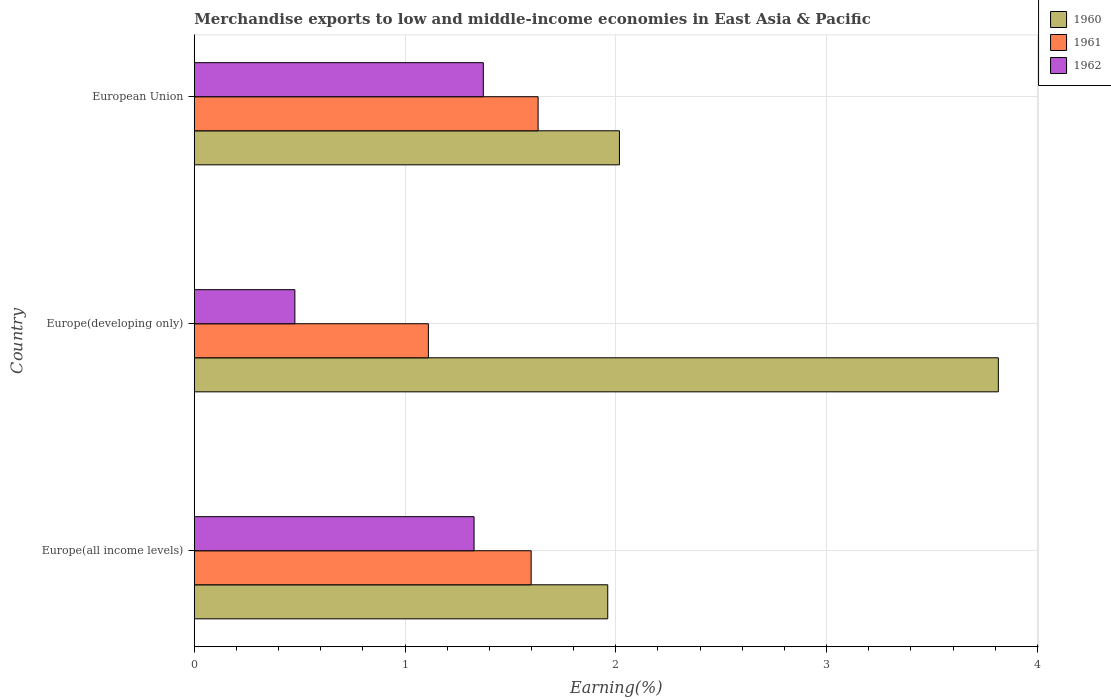How many groups of bars are there?
Offer a terse response. 3. Are the number of bars per tick equal to the number of legend labels?
Keep it short and to the point. Yes. What is the label of the 3rd group of bars from the top?
Your answer should be very brief. Europe(all income levels). What is the percentage of amount earned from merchandise exports in 1961 in European Union?
Offer a very short reply. 1.63. Across all countries, what is the maximum percentage of amount earned from merchandise exports in 1961?
Make the answer very short. 1.63. Across all countries, what is the minimum percentage of amount earned from merchandise exports in 1962?
Make the answer very short. 0.48. In which country was the percentage of amount earned from merchandise exports in 1961 minimum?
Your response must be concise. Europe(developing only). What is the total percentage of amount earned from merchandise exports in 1960 in the graph?
Your response must be concise. 7.79. What is the difference between the percentage of amount earned from merchandise exports in 1962 in Europe(all income levels) and that in European Union?
Provide a short and direct response. -0.04. What is the difference between the percentage of amount earned from merchandise exports in 1962 in Europe(all income levels) and the percentage of amount earned from merchandise exports in 1960 in Europe(developing only)?
Ensure brevity in your answer.  -2.49. What is the average percentage of amount earned from merchandise exports in 1961 per country?
Make the answer very short. 1.45. What is the difference between the percentage of amount earned from merchandise exports in 1960 and percentage of amount earned from merchandise exports in 1961 in European Union?
Make the answer very short. 0.39. In how many countries, is the percentage of amount earned from merchandise exports in 1960 greater than 0.4 %?
Offer a terse response. 3. What is the ratio of the percentage of amount earned from merchandise exports in 1960 in Europe(all income levels) to that in European Union?
Make the answer very short. 0.97. Is the percentage of amount earned from merchandise exports in 1961 in Europe(all income levels) less than that in European Union?
Offer a terse response. Yes. What is the difference between the highest and the second highest percentage of amount earned from merchandise exports in 1960?
Offer a very short reply. 1.8. What is the difference between the highest and the lowest percentage of amount earned from merchandise exports in 1960?
Your answer should be very brief. 1.85. Is the sum of the percentage of amount earned from merchandise exports in 1962 in Europe(developing only) and European Union greater than the maximum percentage of amount earned from merchandise exports in 1960 across all countries?
Keep it short and to the point. No. What is the difference between two consecutive major ticks on the X-axis?
Provide a short and direct response. 1. Does the graph contain any zero values?
Provide a short and direct response. No. Does the graph contain grids?
Give a very brief answer. Yes. Where does the legend appear in the graph?
Your answer should be compact. Top right. How many legend labels are there?
Offer a terse response. 3. How are the legend labels stacked?
Make the answer very short. Vertical. What is the title of the graph?
Your answer should be compact. Merchandise exports to low and middle-income economies in East Asia & Pacific. Does "1994" appear as one of the legend labels in the graph?
Offer a very short reply. No. What is the label or title of the X-axis?
Provide a succinct answer. Earning(%). What is the label or title of the Y-axis?
Your answer should be compact. Country. What is the Earning(%) of 1960 in Europe(all income levels)?
Keep it short and to the point. 1.96. What is the Earning(%) of 1961 in Europe(all income levels)?
Your answer should be compact. 1.6. What is the Earning(%) in 1962 in Europe(all income levels)?
Give a very brief answer. 1.33. What is the Earning(%) in 1960 in Europe(developing only)?
Your answer should be compact. 3.82. What is the Earning(%) in 1961 in Europe(developing only)?
Offer a very short reply. 1.11. What is the Earning(%) in 1962 in Europe(developing only)?
Your answer should be very brief. 0.48. What is the Earning(%) of 1960 in European Union?
Your answer should be very brief. 2.02. What is the Earning(%) in 1961 in European Union?
Ensure brevity in your answer.  1.63. What is the Earning(%) of 1962 in European Union?
Provide a short and direct response. 1.37. Across all countries, what is the maximum Earning(%) in 1960?
Keep it short and to the point. 3.82. Across all countries, what is the maximum Earning(%) in 1961?
Your answer should be compact. 1.63. Across all countries, what is the maximum Earning(%) in 1962?
Your answer should be compact. 1.37. Across all countries, what is the minimum Earning(%) in 1960?
Ensure brevity in your answer.  1.96. Across all countries, what is the minimum Earning(%) in 1961?
Your answer should be very brief. 1.11. Across all countries, what is the minimum Earning(%) in 1962?
Provide a short and direct response. 0.48. What is the total Earning(%) in 1960 in the graph?
Offer a terse response. 7.79. What is the total Earning(%) in 1961 in the graph?
Offer a very short reply. 4.34. What is the total Earning(%) in 1962 in the graph?
Offer a terse response. 3.18. What is the difference between the Earning(%) in 1960 in Europe(all income levels) and that in Europe(developing only)?
Your answer should be very brief. -1.85. What is the difference between the Earning(%) in 1961 in Europe(all income levels) and that in Europe(developing only)?
Provide a succinct answer. 0.49. What is the difference between the Earning(%) in 1962 in Europe(all income levels) and that in Europe(developing only)?
Your answer should be compact. 0.85. What is the difference between the Earning(%) of 1960 in Europe(all income levels) and that in European Union?
Give a very brief answer. -0.06. What is the difference between the Earning(%) of 1961 in Europe(all income levels) and that in European Union?
Give a very brief answer. -0.03. What is the difference between the Earning(%) in 1962 in Europe(all income levels) and that in European Union?
Provide a succinct answer. -0.04. What is the difference between the Earning(%) of 1960 in Europe(developing only) and that in European Union?
Your answer should be compact. 1.8. What is the difference between the Earning(%) of 1961 in Europe(developing only) and that in European Union?
Offer a very short reply. -0.52. What is the difference between the Earning(%) in 1962 in Europe(developing only) and that in European Union?
Your answer should be very brief. -0.89. What is the difference between the Earning(%) of 1960 in Europe(all income levels) and the Earning(%) of 1961 in Europe(developing only)?
Your answer should be compact. 0.85. What is the difference between the Earning(%) of 1960 in Europe(all income levels) and the Earning(%) of 1962 in Europe(developing only)?
Your answer should be very brief. 1.48. What is the difference between the Earning(%) of 1961 in Europe(all income levels) and the Earning(%) of 1962 in Europe(developing only)?
Offer a terse response. 1.12. What is the difference between the Earning(%) in 1960 in Europe(all income levels) and the Earning(%) in 1961 in European Union?
Provide a succinct answer. 0.33. What is the difference between the Earning(%) of 1960 in Europe(all income levels) and the Earning(%) of 1962 in European Union?
Your answer should be compact. 0.59. What is the difference between the Earning(%) of 1961 in Europe(all income levels) and the Earning(%) of 1962 in European Union?
Offer a terse response. 0.23. What is the difference between the Earning(%) of 1960 in Europe(developing only) and the Earning(%) of 1961 in European Union?
Your answer should be compact. 2.18. What is the difference between the Earning(%) of 1960 in Europe(developing only) and the Earning(%) of 1962 in European Union?
Keep it short and to the point. 2.44. What is the difference between the Earning(%) of 1961 in Europe(developing only) and the Earning(%) of 1962 in European Union?
Your answer should be compact. -0.26. What is the average Earning(%) in 1960 per country?
Provide a short and direct response. 2.6. What is the average Earning(%) in 1961 per country?
Offer a very short reply. 1.45. What is the average Earning(%) in 1962 per country?
Offer a very short reply. 1.06. What is the difference between the Earning(%) in 1960 and Earning(%) in 1961 in Europe(all income levels)?
Your response must be concise. 0.36. What is the difference between the Earning(%) of 1960 and Earning(%) of 1962 in Europe(all income levels)?
Give a very brief answer. 0.63. What is the difference between the Earning(%) in 1961 and Earning(%) in 1962 in Europe(all income levels)?
Ensure brevity in your answer.  0.27. What is the difference between the Earning(%) of 1960 and Earning(%) of 1961 in Europe(developing only)?
Ensure brevity in your answer.  2.7. What is the difference between the Earning(%) in 1960 and Earning(%) in 1962 in Europe(developing only)?
Make the answer very short. 3.34. What is the difference between the Earning(%) in 1961 and Earning(%) in 1962 in Europe(developing only)?
Ensure brevity in your answer.  0.63. What is the difference between the Earning(%) in 1960 and Earning(%) in 1961 in European Union?
Ensure brevity in your answer.  0.39. What is the difference between the Earning(%) in 1960 and Earning(%) in 1962 in European Union?
Offer a terse response. 0.65. What is the difference between the Earning(%) of 1961 and Earning(%) of 1962 in European Union?
Keep it short and to the point. 0.26. What is the ratio of the Earning(%) in 1960 in Europe(all income levels) to that in Europe(developing only)?
Your answer should be very brief. 0.51. What is the ratio of the Earning(%) in 1961 in Europe(all income levels) to that in Europe(developing only)?
Provide a short and direct response. 1.44. What is the ratio of the Earning(%) in 1962 in Europe(all income levels) to that in Europe(developing only)?
Your response must be concise. 2.78. What is the ratio of the Earning(%) in 1960 in Europe(all income levels) to that in European Union?
Provide a short and direct response. 0.97. What is the ratio of the Earning(%) of 1961 in Europe(all income levels) to that in European Union?
Keep it short and to the point. 0.98. What is the ratio of the Earning(%) in 1960 in Europe(developing only) to that in European Union?
Keep it short and to the point. 1.89. What is the ratio of the Earning(%) of 1961 in Europe(developing only) to that in European Union?
Keep it short and to the point. 0.68. What is the ratio of the Earning(%) in 1962 in Europe(developing only) to that in European Union?
Ensure brevity in your answer.  0.35. What is the difference between the highest and the second highest Earning(%) of 1960?
Your answer should be very brief. 1.8. What is the difference between the highest and the second highest Earning(%) of 1961?
Provide a short and direct response. 0.03. What is the difference between the highest and the second highest Earning(%) of 1962?
Your answer should be compact. 0.04. What is the difference between the highest and the lowest Earning(%) in 1960?
Provide a short and direct response. 1.85. What is the difference between the highest and the lowest Earning(%) of 1961?
Provide a succinct answer. 0.52. What is the difference between the highest and the lowest Earning(%) in 1962?
Keep it short and to the point. 0.89. 